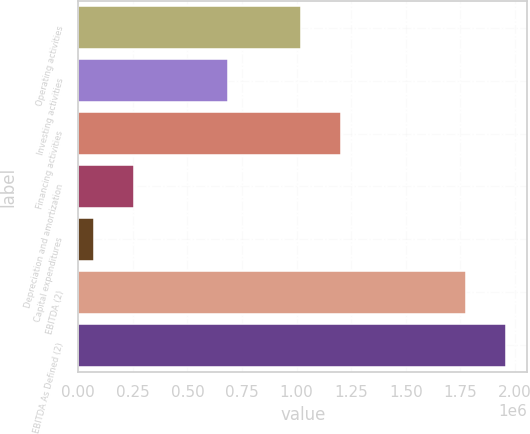<chart> <loc_0><loc_0><loc_500><loc_500><bar_chart><fcel>Operating activities<fcel>Investing activities<fcel>Financing activities<fcel>Depreciation and amortization<fcel>Capital expenditures<fcel>EBITDA (2)<fcel>EBITDA As Defined (2)<nl><fcel>1.02217e+06<fcel>683577<fcel>1.20249e+06<fcel>253663<fcel>73341<fcel>1.77841e+06<fcel>1.95873e+06<nl></chart> 